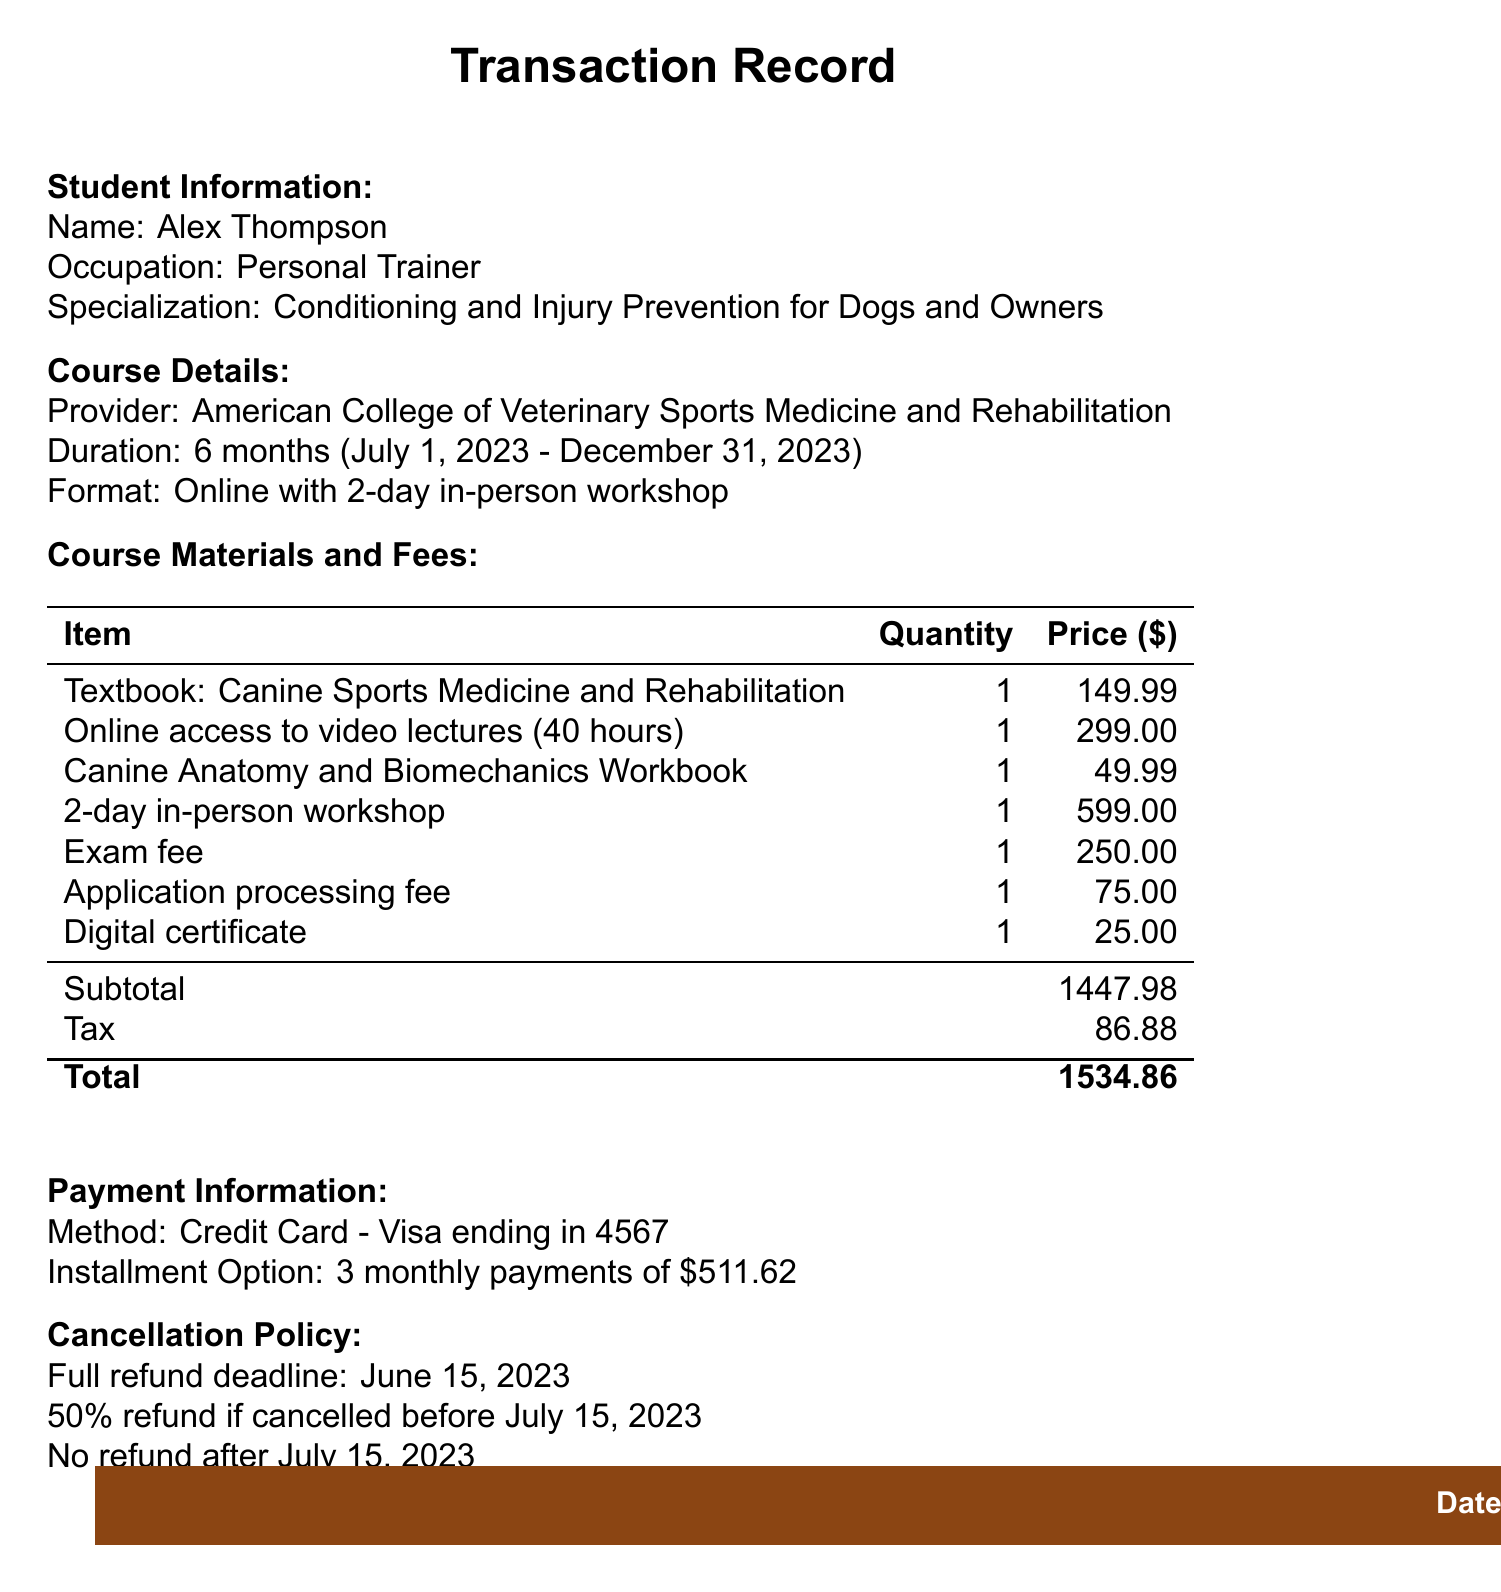What is the transaction ID? The transaction ID is a unique identifier for the transaction listed at the top of the document.
Answer: CSM2023-0584 What is the date of the transaction? The date indicates when the registration and payment occurred, specified in the document.
Answer: 2023-05-15 Who is the instructor of the workshop? The instructor's name is mentioned under the workshop details, providing knowledge of who is leading the course.
Answer: Dr. Evelyn Orenbuch, DVM, DACVSMR What is the total amount paid? The total paid is calculated by summing the subtotal and tax, presented at the end of the payment information section.
Answer: 1534.86 When does the course start? The start date of the course is mentioned in the course details, indicating when the instruction begins.
Answer: 2023-07-01 How many payments are offered in the installment option? The installment option details the number of payments available for payment plan selection.
Answer: 3 What is the refund policy after July 15, 2023? The specific condition highlights the rules regarding refunds related to cancellation after a certain date.
Answer: No refund after 2023-07-15 What is the duration of the exam? The exam duration specifies how long students have to complete the test, detailed in the exam section.
Answer: 3 hours What is included in the course materials? This encompasses the items that students will receive as part of their course materials and fees.
Answer: Textbook, video lectures, workbook 